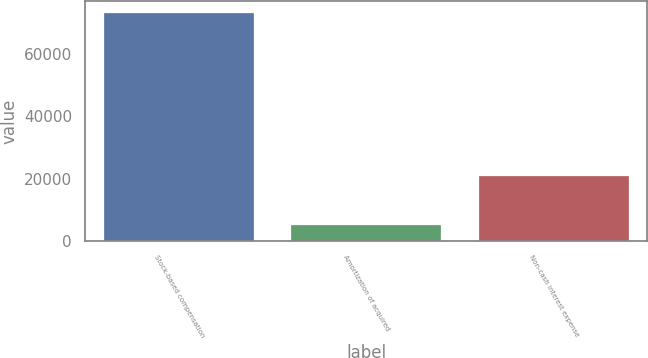Convert chart. <chart><loc_0><loc_0><loc_500><loc_500><bar_chart><fcel>Stock-based compensation<fcel>Amortization of acquired<fcel>Non-cash interest expense<nl><fcel>73266<fcel>4942<fcel>20722<nl></chart> 